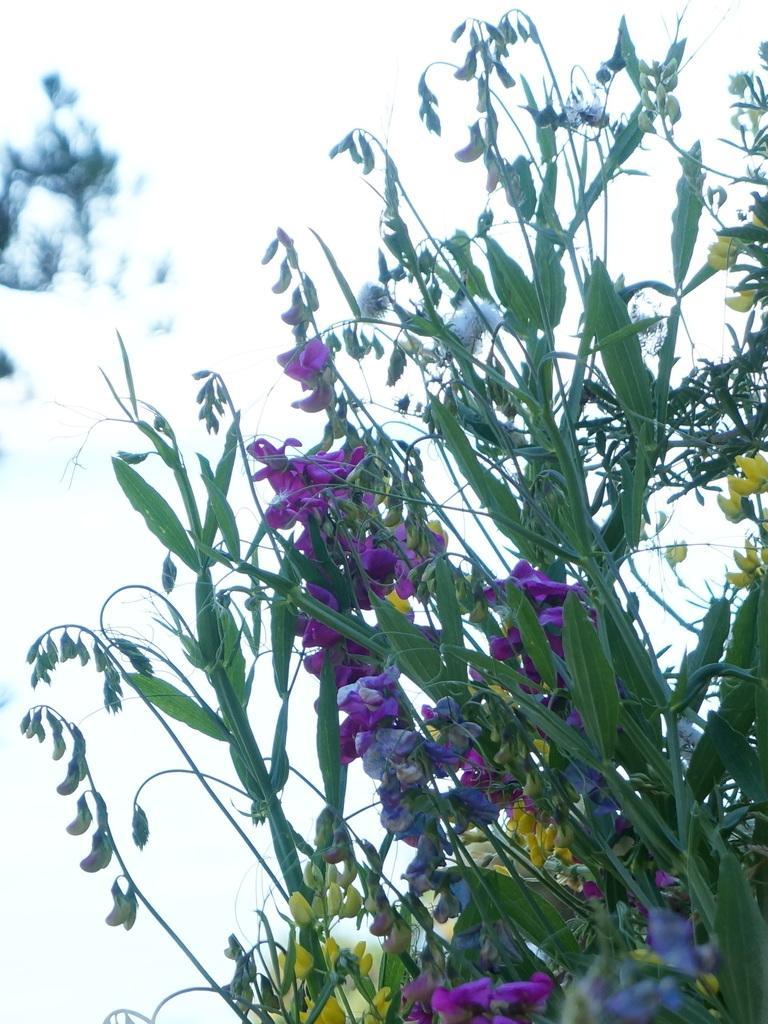Could you give a brief overview of what you see in this image? In the center of the image we can see plant, flowers, leaves, buds. In the background the image is blur. 